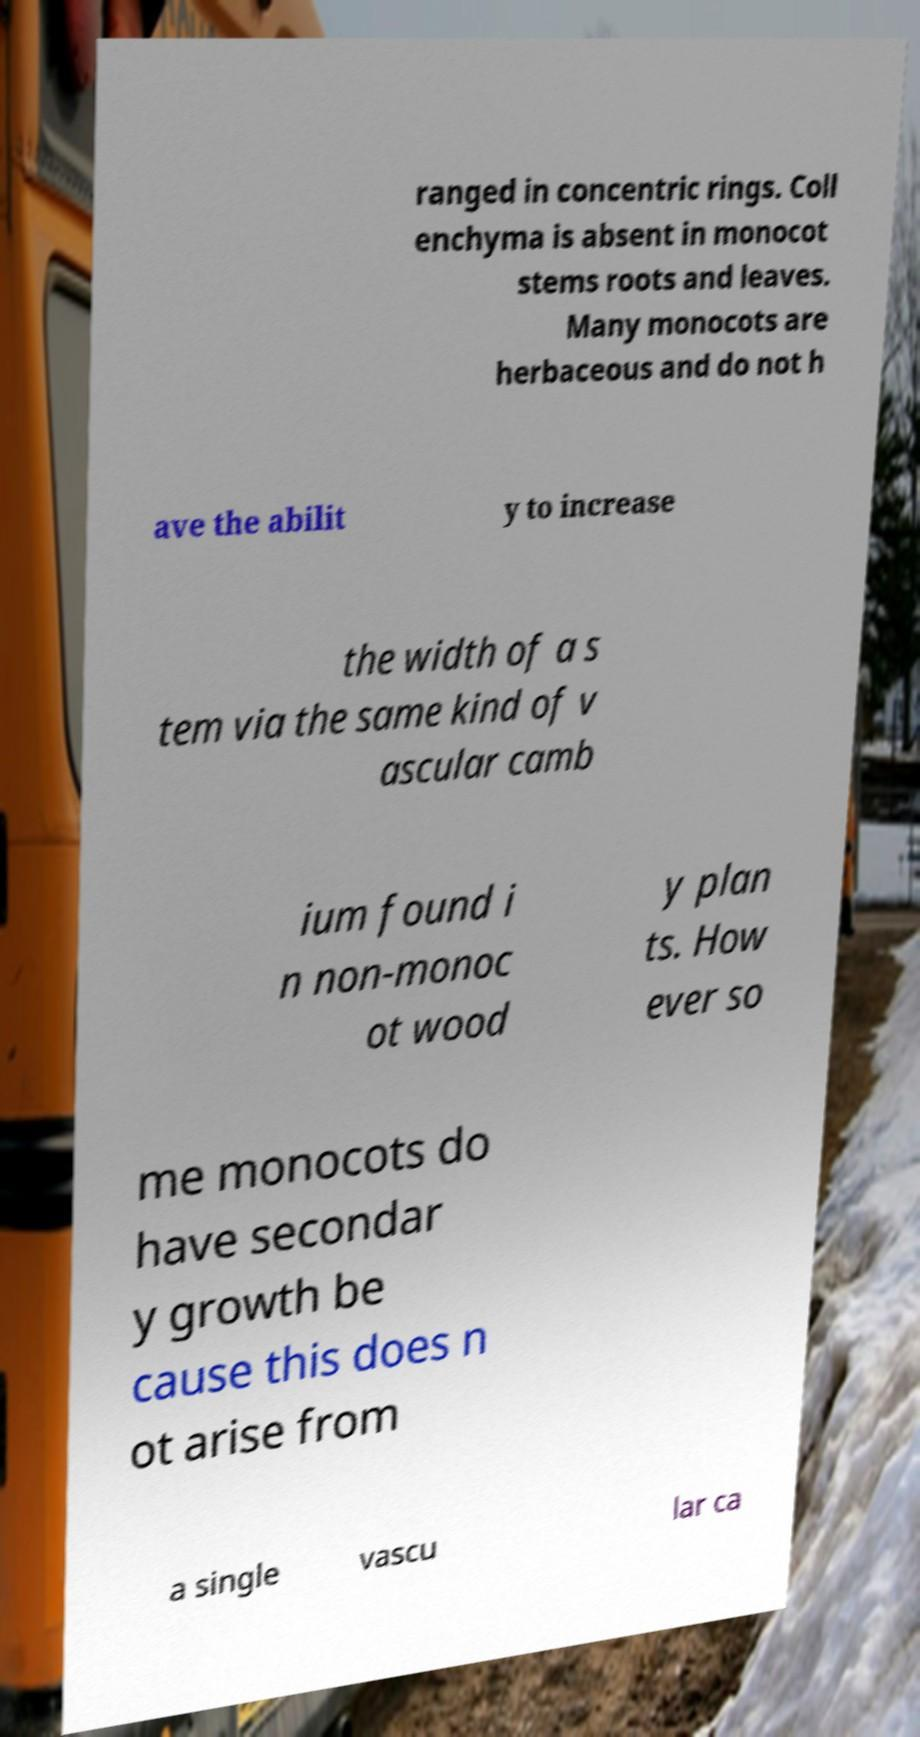There's text embedded in this image that I need extracted. Can you transcribe it verbatim? ranged in concentric rings. Coll enchyma is absent in monocot stems roots and leaves. Many monocots are herbaceous and do not h ave the abilit y to increase the width of a s tem via the same kind of v ascular camb ium found i n non-monoc ot wood y plan ts. How ever so me monocots do have secondar y growth be cause this does n ot arise from a single vascu lar ca 